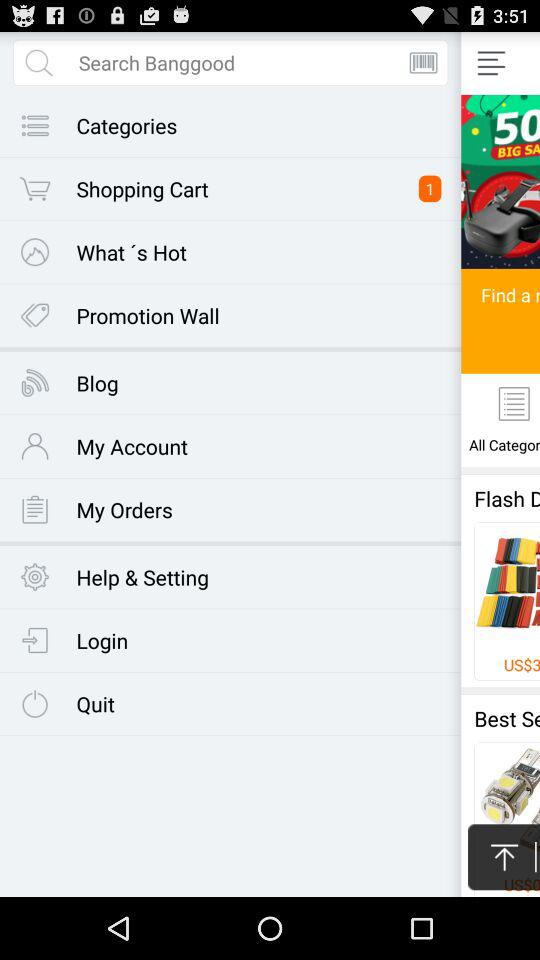How many answers are there? There is one answer. 